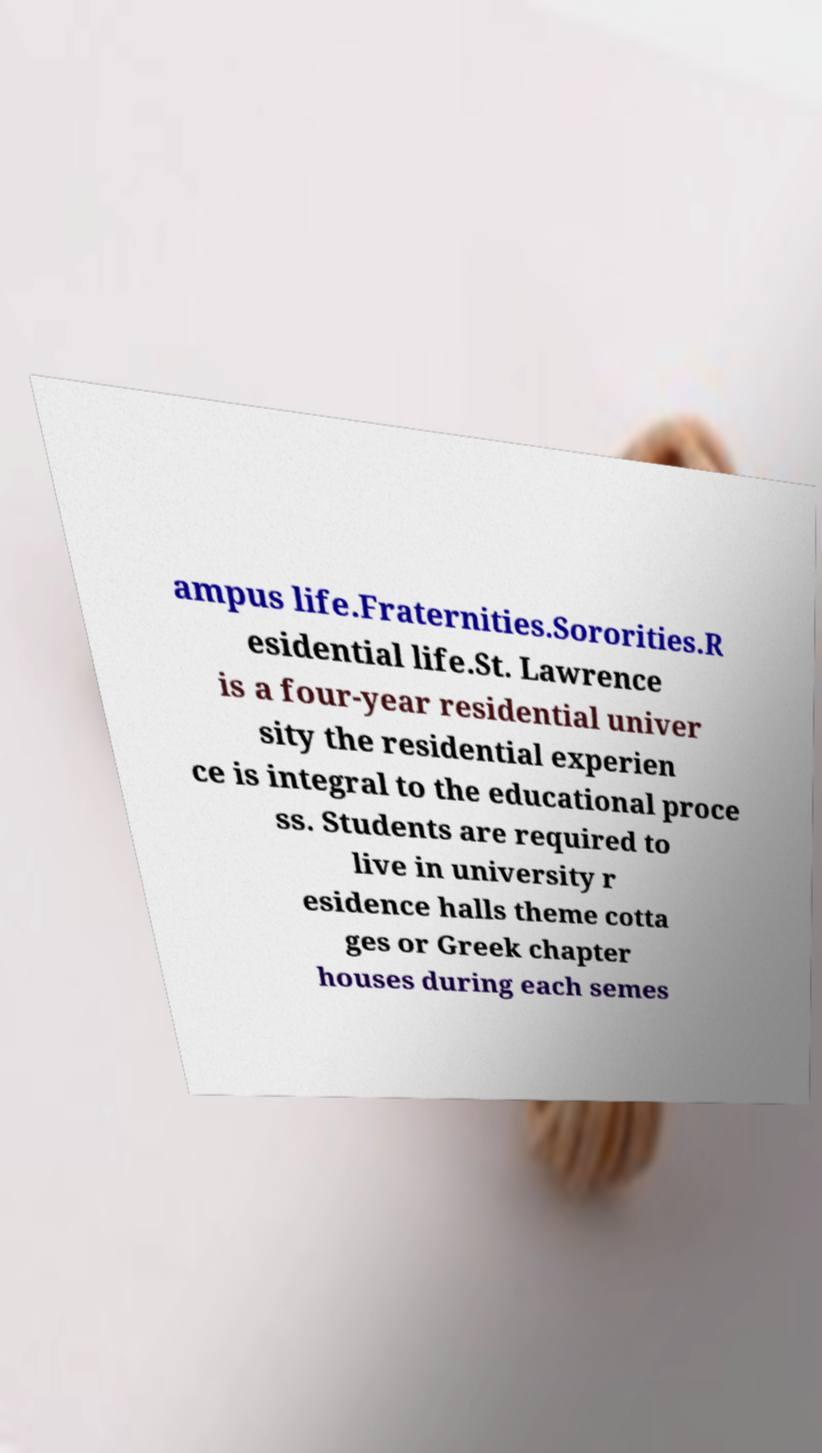Can you accurately transcribe the text from the provided image for me? ampus life.Fraternities.Sororities.R esidential life.St. Lawrence is a four-year residential univer sity the residential experien ce is integral to the educational proce ss. Students are required to live in university r esidence halls theme cotta ges or Greek chapter houses during each semes 